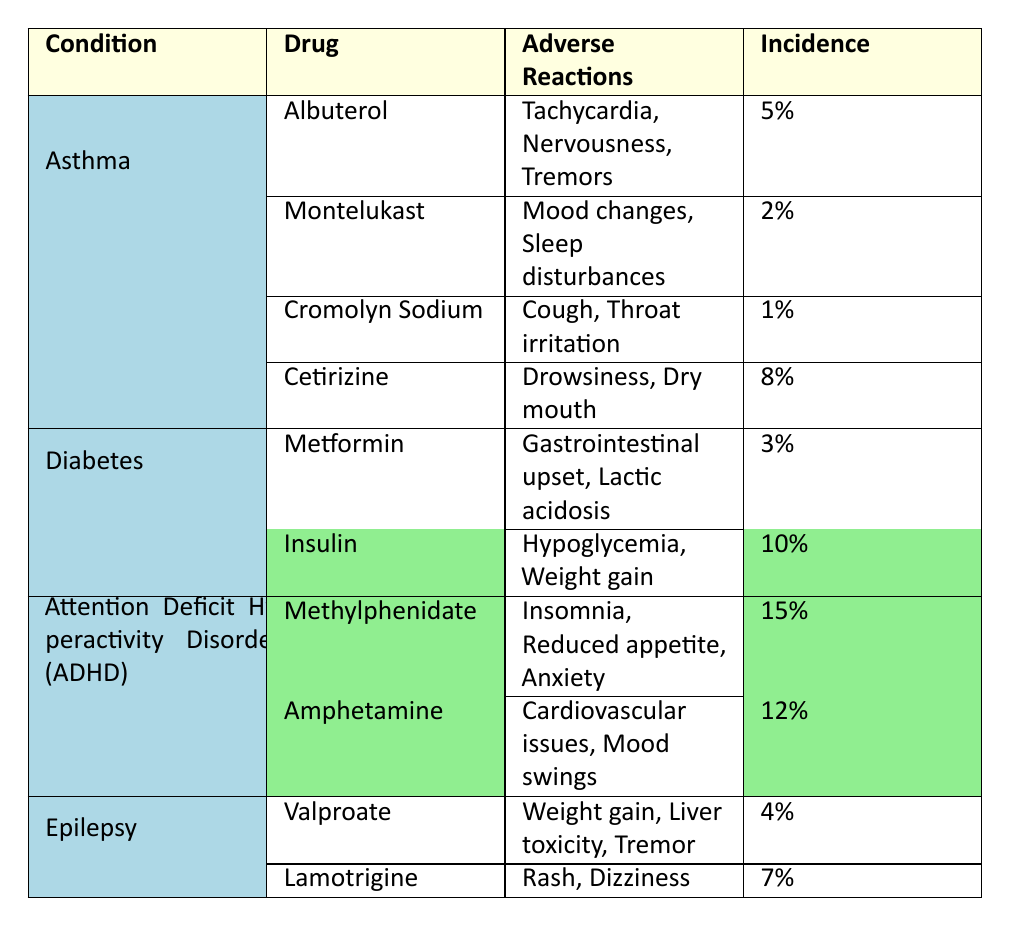What is the adverse reaction with the highest incidence among the listed drugs? By reviewing the "Incidence" column in the table, we see that Methylphenidate has the highest incidence at 15%.
Answer: 15% Which condition has the least adverse reactions listed for its associated drugs? Upon examining the "Adverse Reactions" column, we find that Cromolyn Sodium for the Asthma and Allergies condition has the least adverse reactions listed, with only two: Cough and Throat irritation.
Answer: Asthma and Allergies How many drugs are listed for treating Asthma? In the table, we count the drugs under the row for the Asthma condition: Albuterol, Montelukast, Cromolyn Sodium, and Cetirizine. This totals to four drugs.
Answer: 4 Which drug associated with ADHD has the highest incidence? The Drugs listed under ADHD, Methylphenidate and Amphetamine, have incidences of 15% and 12% respectively. Methylphenidate, with 15%, has the highest incidence.
Answer: Methylphenidate Is it true that all drugs for Diabetes have an incidence greater than 5%? Checking the "Incidence" column for Diabetes drugs, we see Metformin has an incidence of 3%. Therefore, not all drugs exceed 5%.
Answer: No What is the total incidence percentage of all adverse reactions listed for epilepsy? Adding the incidence of Valproate (4%) and Lamotrigine (7%) gives us a total of 11%.
Answer: 11% For Asthma-related drugs, which adverse reaction has the higher incidence, Nervousness or Drowsiness? Nervousness has an incidence linked to Albuterol (5%), while Drowsiness is associated with Cetirizine (8%). Comparing the two, Drowsiness has the higher incidence.
Answer: Drowsiness What is the average incidence of drugs for ADHD? To find the average, add the incidences of Methylphenidate (15%) and Amphetamine (12%), which totals 27%. Dividing by the number of drugs (2) gives an average of 13.5%.
Answer: 13.5% Which condition has the highest number of adverse reactions listed from its associated drugs? The condition ADHD has three listed adverse reactions for Methylphenidate (Insomnia, Reduced appetite, Anxiety) and two for Amphetamine (Cardiovascular issues, Mood swings). Since three is the highest number, ADHD holds this distinction.
Answer: ADHD Which drug has the lowest incidence overall? Examining the incidence percentages in the table, Cromolyn Sodium shows the lowest incidence at 1%.
Answer: 1% 